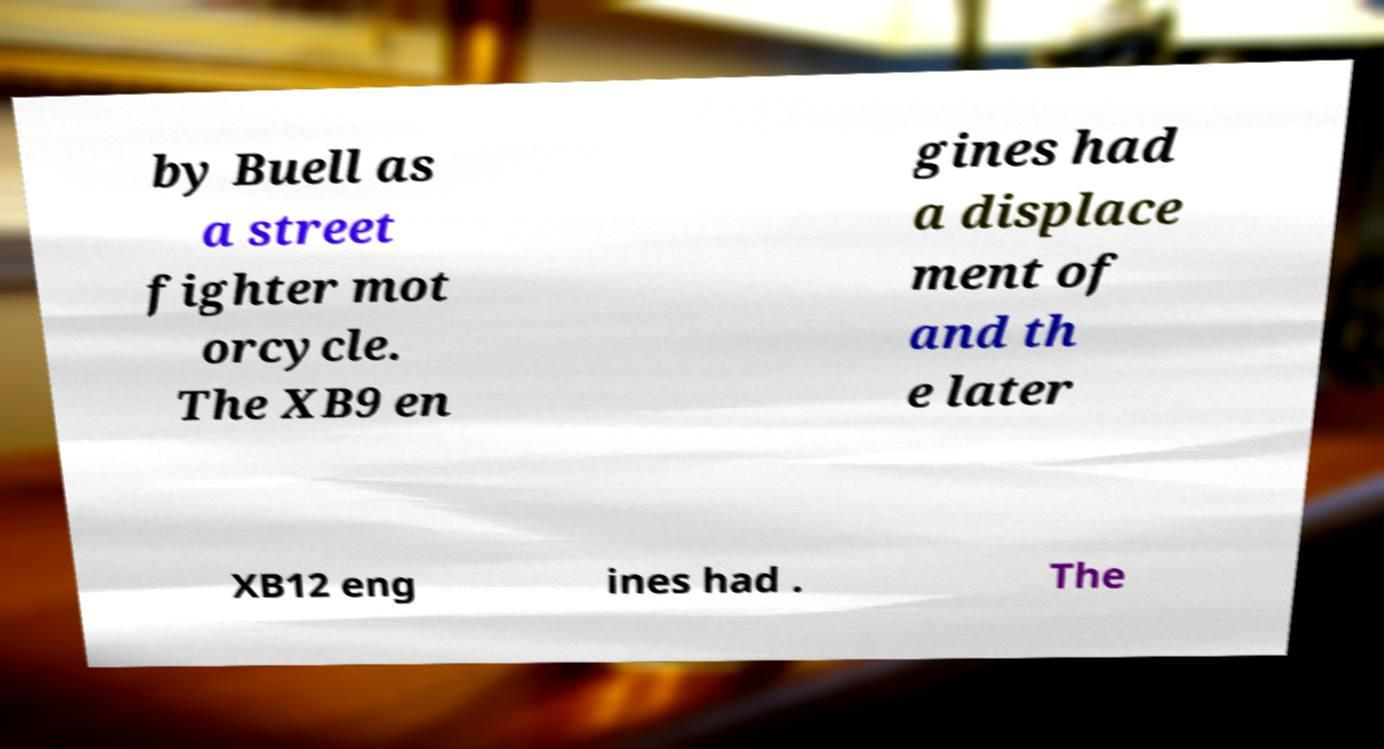For documentation purposes, I need the text within this image transcribed. Could you provide that? by Buell as a street fighter mot orcycle. The XB9 en gines had a displace ment of and th e later XB12 eng ines had . The 